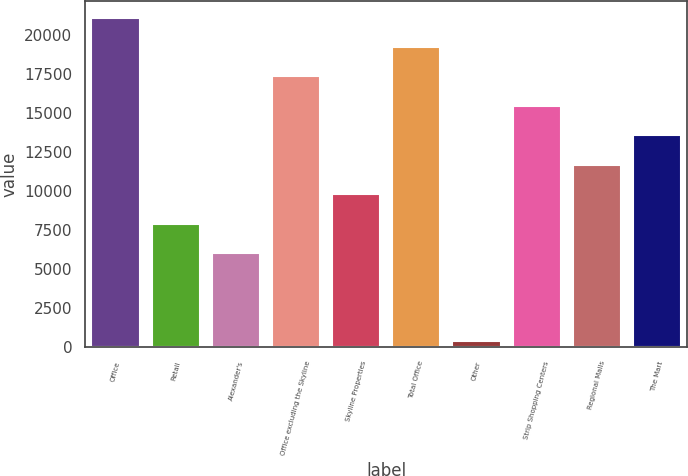Convert chart. <chart><loc_0><loc_0><loc_500><loc_500><bar_chart><fcel>Office<fcel>Retail<fcel>Alexander's<fcel>Office excluding the Skyline<fcel>Skyline Properties<fcel>Total Office<fcel>Other<fcel>Strip Shopping Centers<fcel>Regional Malls<fcel>The Mart<nl><fcel>21100.8<fcel>7914.2<fcel>6030.4<fcel>17333.2<fcel>9798<fcel>19217<fcel>379<fcel>15449.4<fcel>11681.8<fcel>13565.6<nl></chart> 